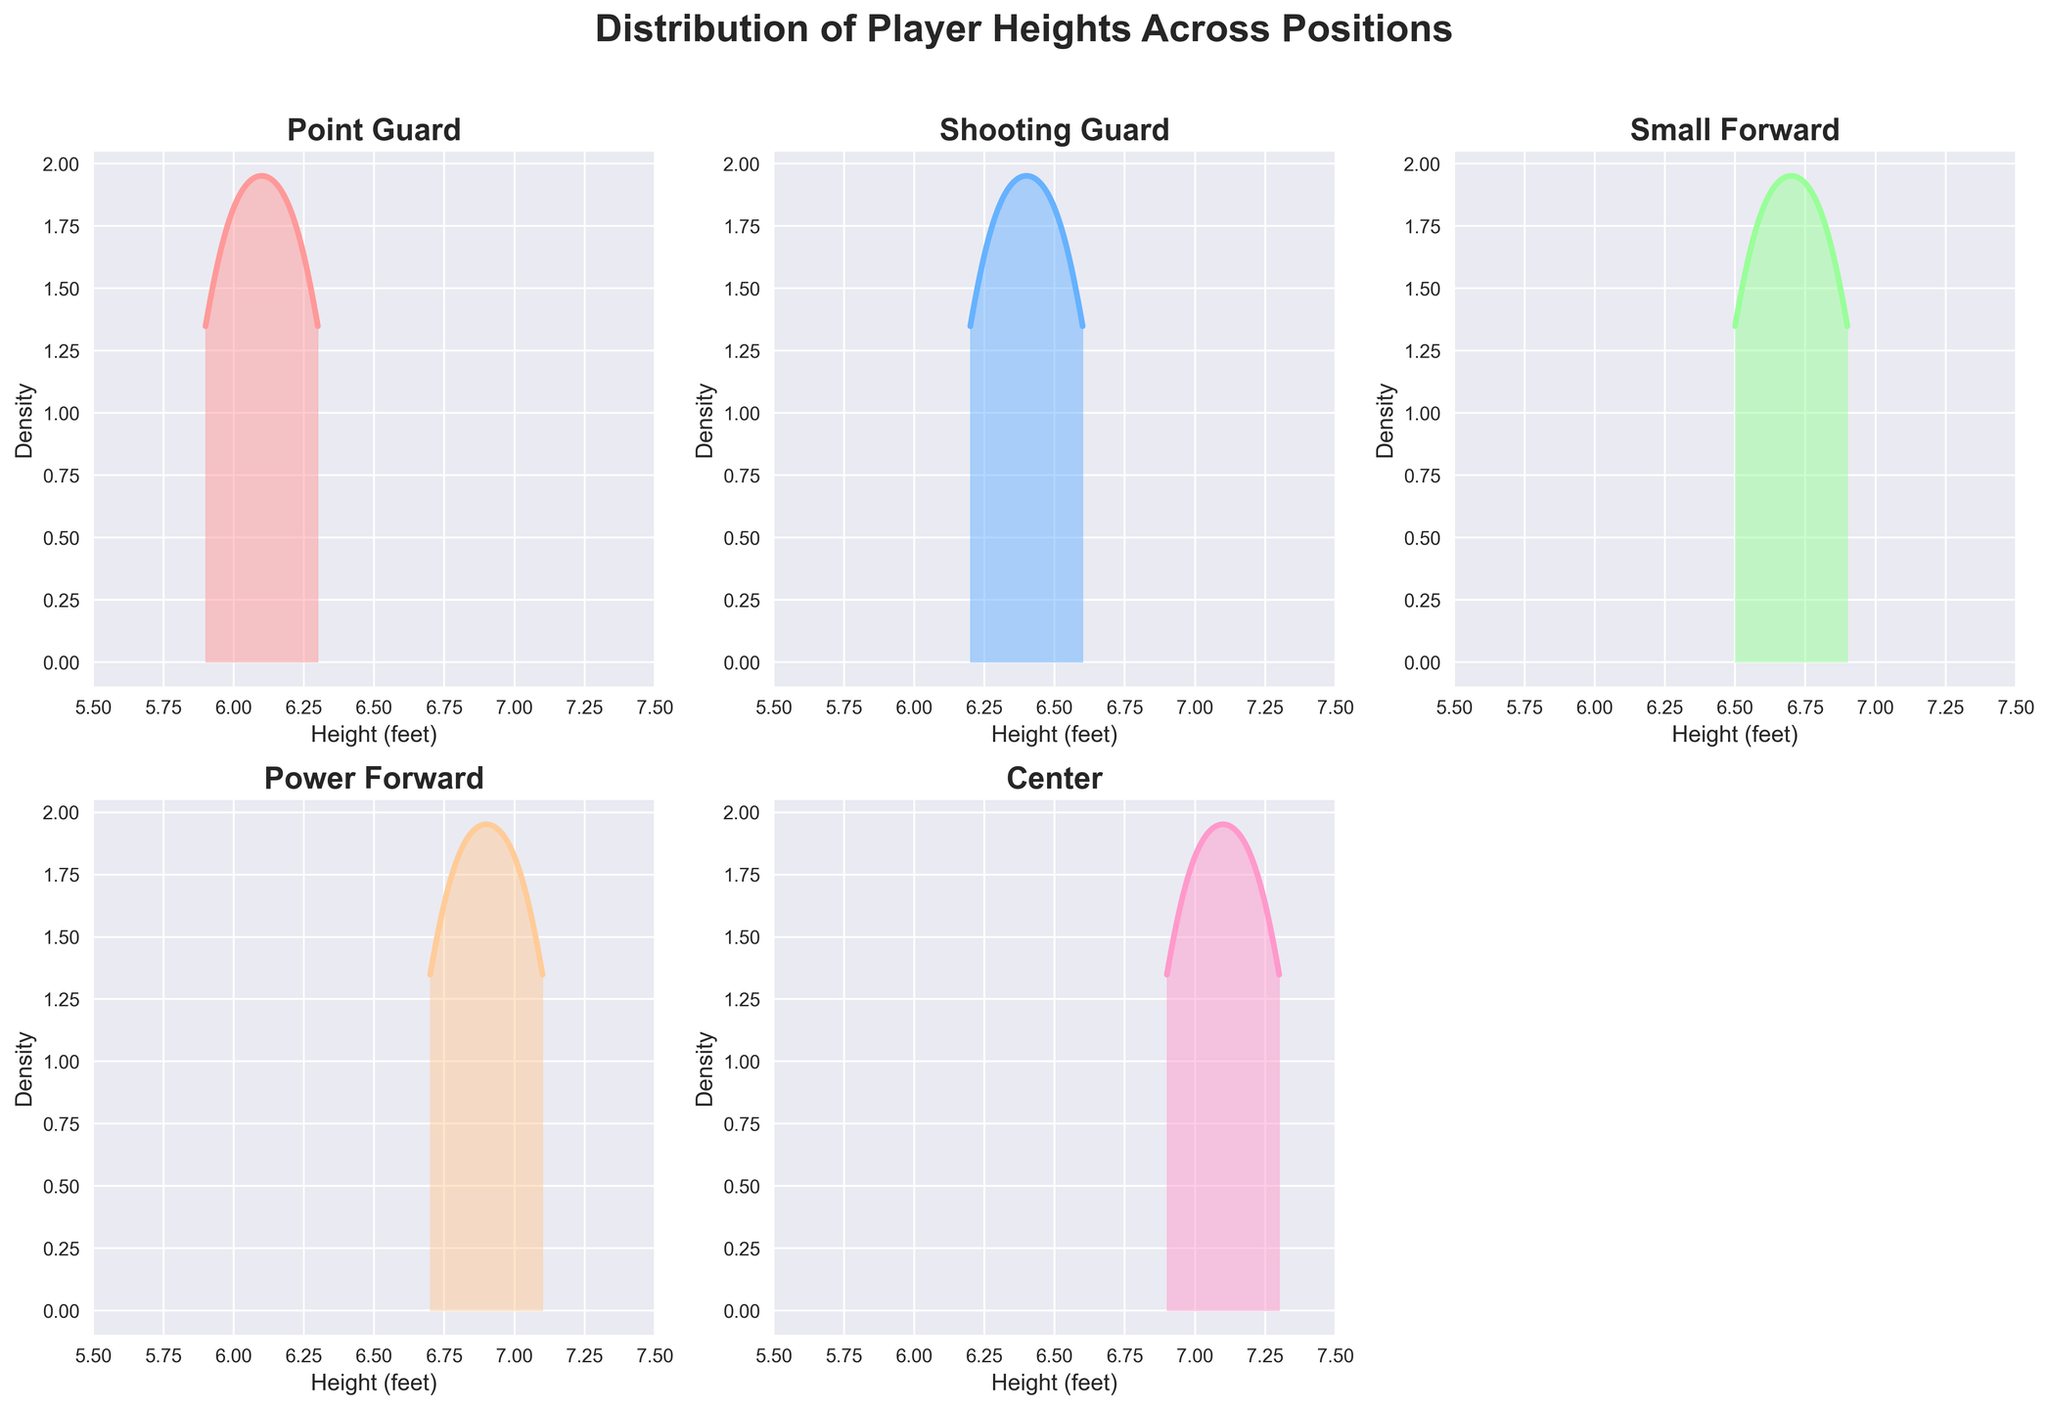Which position has the tallest players on average based on the density plots? By observing the density plots, the tallest average heights are found in the Center position's distribution as the peak lies farther to the right.
Answer: Center What is the height range visible for all positions in the plots? All subplots use a consistent x-axis to represent player heights, ranging from 5.5 to 7.5 feet.
Answer: 5.5 to 7.5 feet Among all positions, which one has the most compact height distribution? The most compact distribution is identified by the density plot having the least spread. The Point Guard's density is more concentrated, showing less spread compared to others.
Answer: Point Guard Which two positions have overlapping regions in their density plots indicating similar height ranges? Examining the density plots, Shooting Guard and Small Forward show overlapping regions, indicating some shared height ranges.
Answer: Shooting Guard and Small Forward Based on the density plots, which position might have the least variability in player heights? The position with density curves that show a sharp peak and less spread suggests the least variability, which is observed in the Point Guard plot.
Answer: Point Guard In which subplot do the players' heights start at the highest value (leftmost part of the curve)? By looking at where each density plot starts from the left, the Center position has the highest starting value on the x-axis.
Answer: Center Compared to Point Guards, do Power Forwards generally appear taller? Observing and comparing the density peaks of Point Guards and Power Forwards, the Power Forwards' density peak is positioned to the right, indicating taller average heights.
Answer: Yes Do Small Forwards have a wider height distribution than Centers? By comparing the spread (width) of the density plots, Small Forwards exhibit a wider spread compared to the more concentrated distribution of Centers.
Answer: Yes 